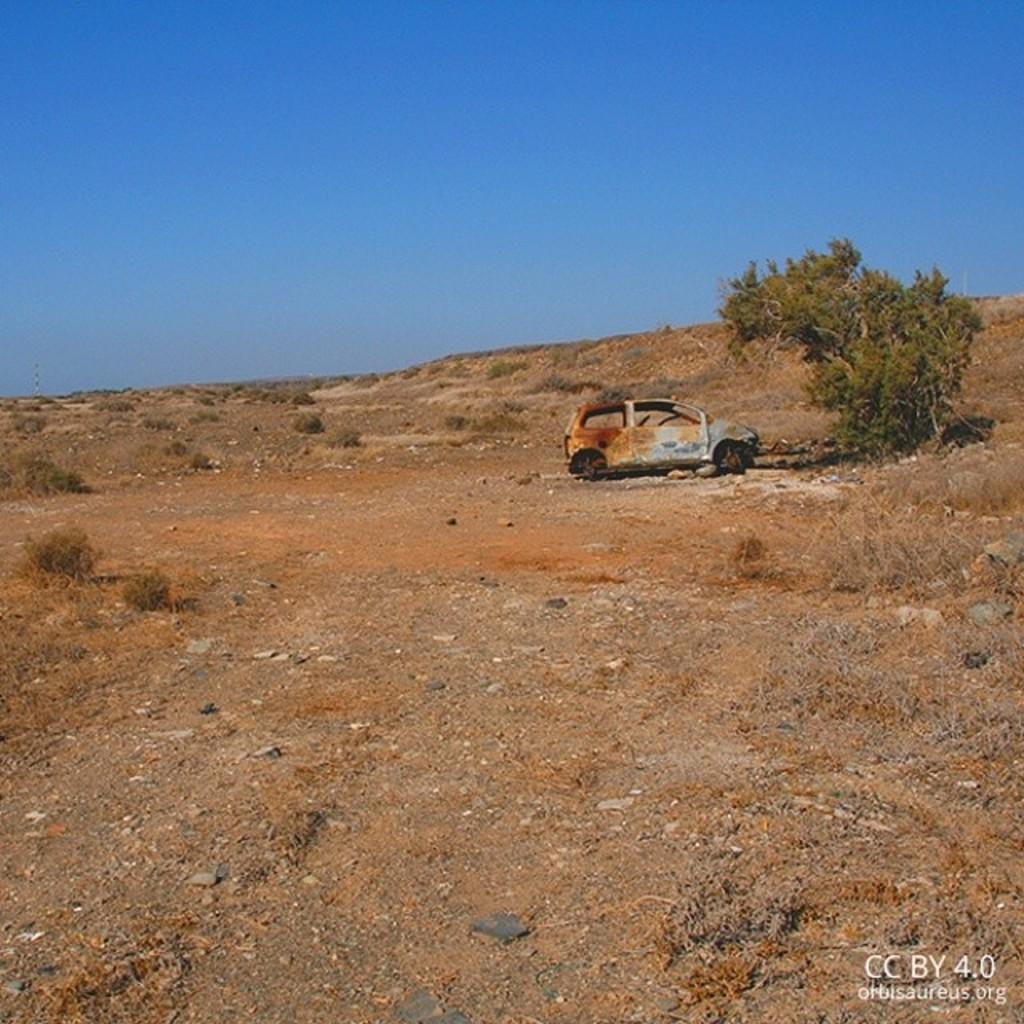What is the main object on the ground in the image? There is an abandoned car on the ground in the image. What is the car's location in relation to other objects? The car is near a tree in the image. What type of vegetation is present on the ground? There is grass on the ground in the image. What can be seen in the background of the image? The sky is visible in the background of the image. What type of trousers is the car wearing in the image? Cars do not wear trousers, as they are inanimate objects. The question is not relevant to the image. 